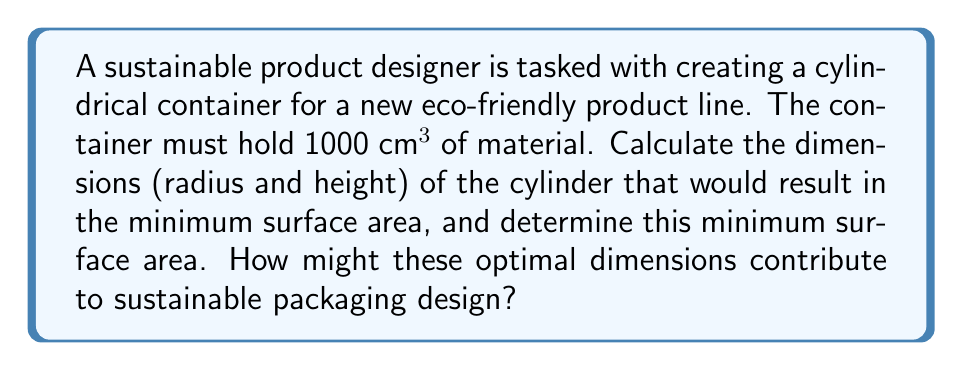Solve this math problem. Let's approach this step-by-step:

1) For a cylinder, we have:
   Volume: $V = \pi r^2 h$
   Surface Area: $SA = 2\pi r^2 + 2\pi rh$

2) We're given that $V = 1000$ cm³. Let's express $h$ in terms of $r$:
   $1000 = \pi r^2 h$
   $h = \frac{1000}{\pi r^2}$

3) Now, substitute this into the surface area formula:
   $SA = 2\pi r^2 + 2\pi r(\frac{1000}{\pi r^2})$
   $SA = 2\pi r^2 + \frac{2000}{r}$

4) To find the minimum, we differentiate $SA$ with respect to $r$ and set it to zero:
   $\frac{dSA}{dr} = 4\pi r - \frac{2000}{r^2} = 0$

5) Solve this equation:
   $4\pi r^3 = 2000$
   $r^3 = \frac{500}{\pi}$
   $r = \sqrt[3]{\frac{500}{\pi}} \approx 5.42$ cm

6) Now we can find $h$:
   $h = \frac{1000}{\pi r^2} = \frac{1000}{\pi (\sqrt[3]{\frac{500}{\pi}})^2} = 2\sqrt[3]{\frac{500}{\pi}} \approx 10.84$ cm

7) The minimum surface area is:
   $SA = 2\pi r^2 + 2\pi rh$
   $SA = 2\pi (\sqrt[3]{\frac{500}{\pi}})^2 + 2\pi \sqrt[3]{\frac{500}{\pi}} (2\sqrt[3]{\frac{500}{\pi}})$
   $SA = 2\pi (\sqrt[3]{\frac{500}{\pi}})^2 + 4\pi (\sqrt[3]{\frac{500}{\pi}})^2$
   $SA = 6\pi (\sqrt[3]{\frac{500}{\pi}})^2 \approx 554.99$ cm²

These optimal dimensions contribute to sustainable packaging design by minimizing the amount of material needed to create the container. This reduces resource consumption and waste, aligning with principles of eco-friendly product development. The balanced proportions (height approximately twice the radius) also tend to be stable and efficient for storage and transportation, potentially reducing the environmental impact of logistics.
Answer: The optimal dimensions for the cylindrical container are:
Radius ≈ 5.42 cm
Height ≈ 10.84 cm
Minimum Surface Area ≈ 554.99 cm² 